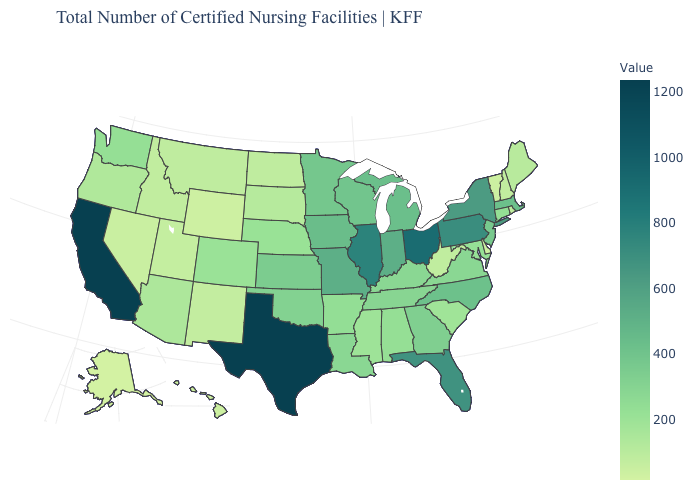Does Alaska have the lowest value in the USA?
Concise answer only. Yes. Which states have the lowest value in the USA?
Short answer required. Alaska. Which states have the lowest value in the West?
Keep it brief. Alaska. Among the states that border New Hampshire , does Maine have the lowest value?
Quick response, please. No. Does the map have missing data?
Quick response, please. No. Which states have the lowest value in the USA?
Answer briefly. Alaska. Among the states that border New Hampshire , does Vermont have the highest value?
Quick response, please. No. 